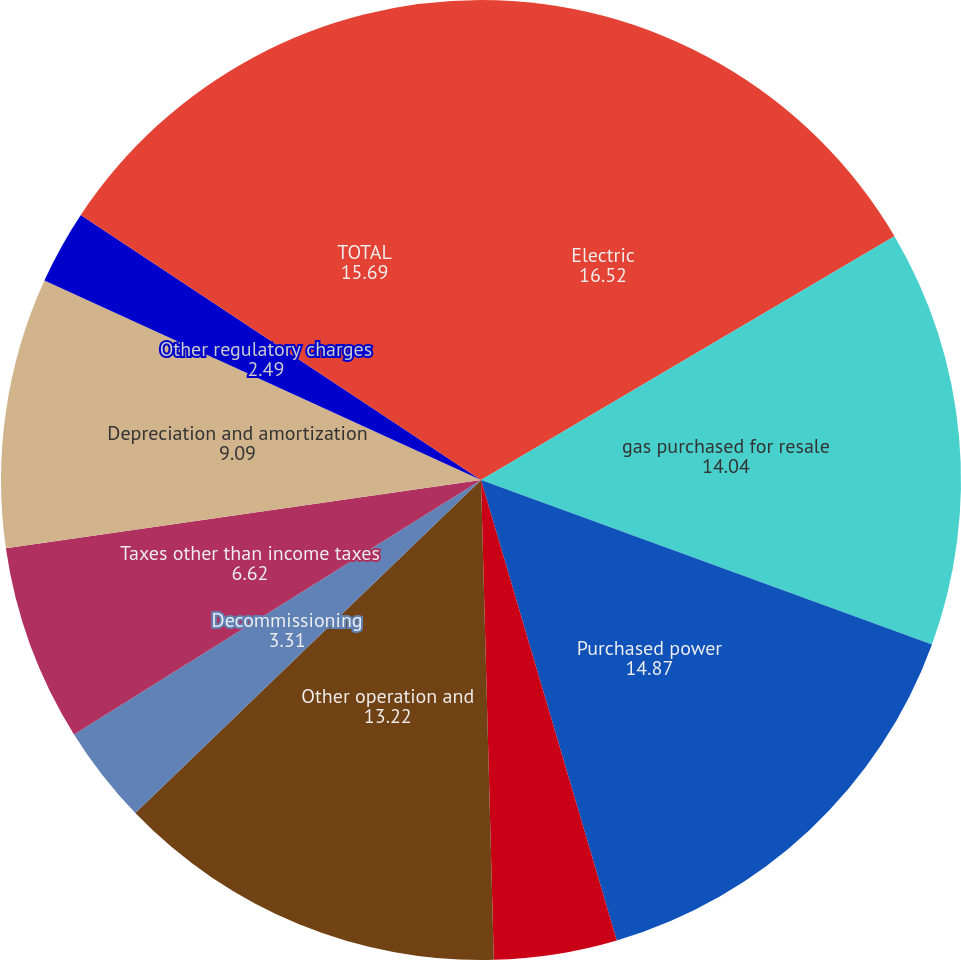Convert chart to OTSL. <chart><loc_0><loc_0><loc_500><loc_500><pie_chart><fcel>Electric<fcel>gas purchased for resale<fcel>Purchased power<fcel>Nuclear refueling outage<fcel>Other operation and<fcel>Decommissioning<fcel>Taxes other than income taxes<fcel>Depreciation and amortization<fcel>Other regulatory charges<fcel>TOTAL<nl><fcel>16.52%<fcel>14.04%<fcel>14.87%<fcel>4.14%<fcel>13.22%<fcel>3.31%<fcel>6.62%<fcel>9.09%<fcel>2.49%<fcel>15.69%<nl></chart> 